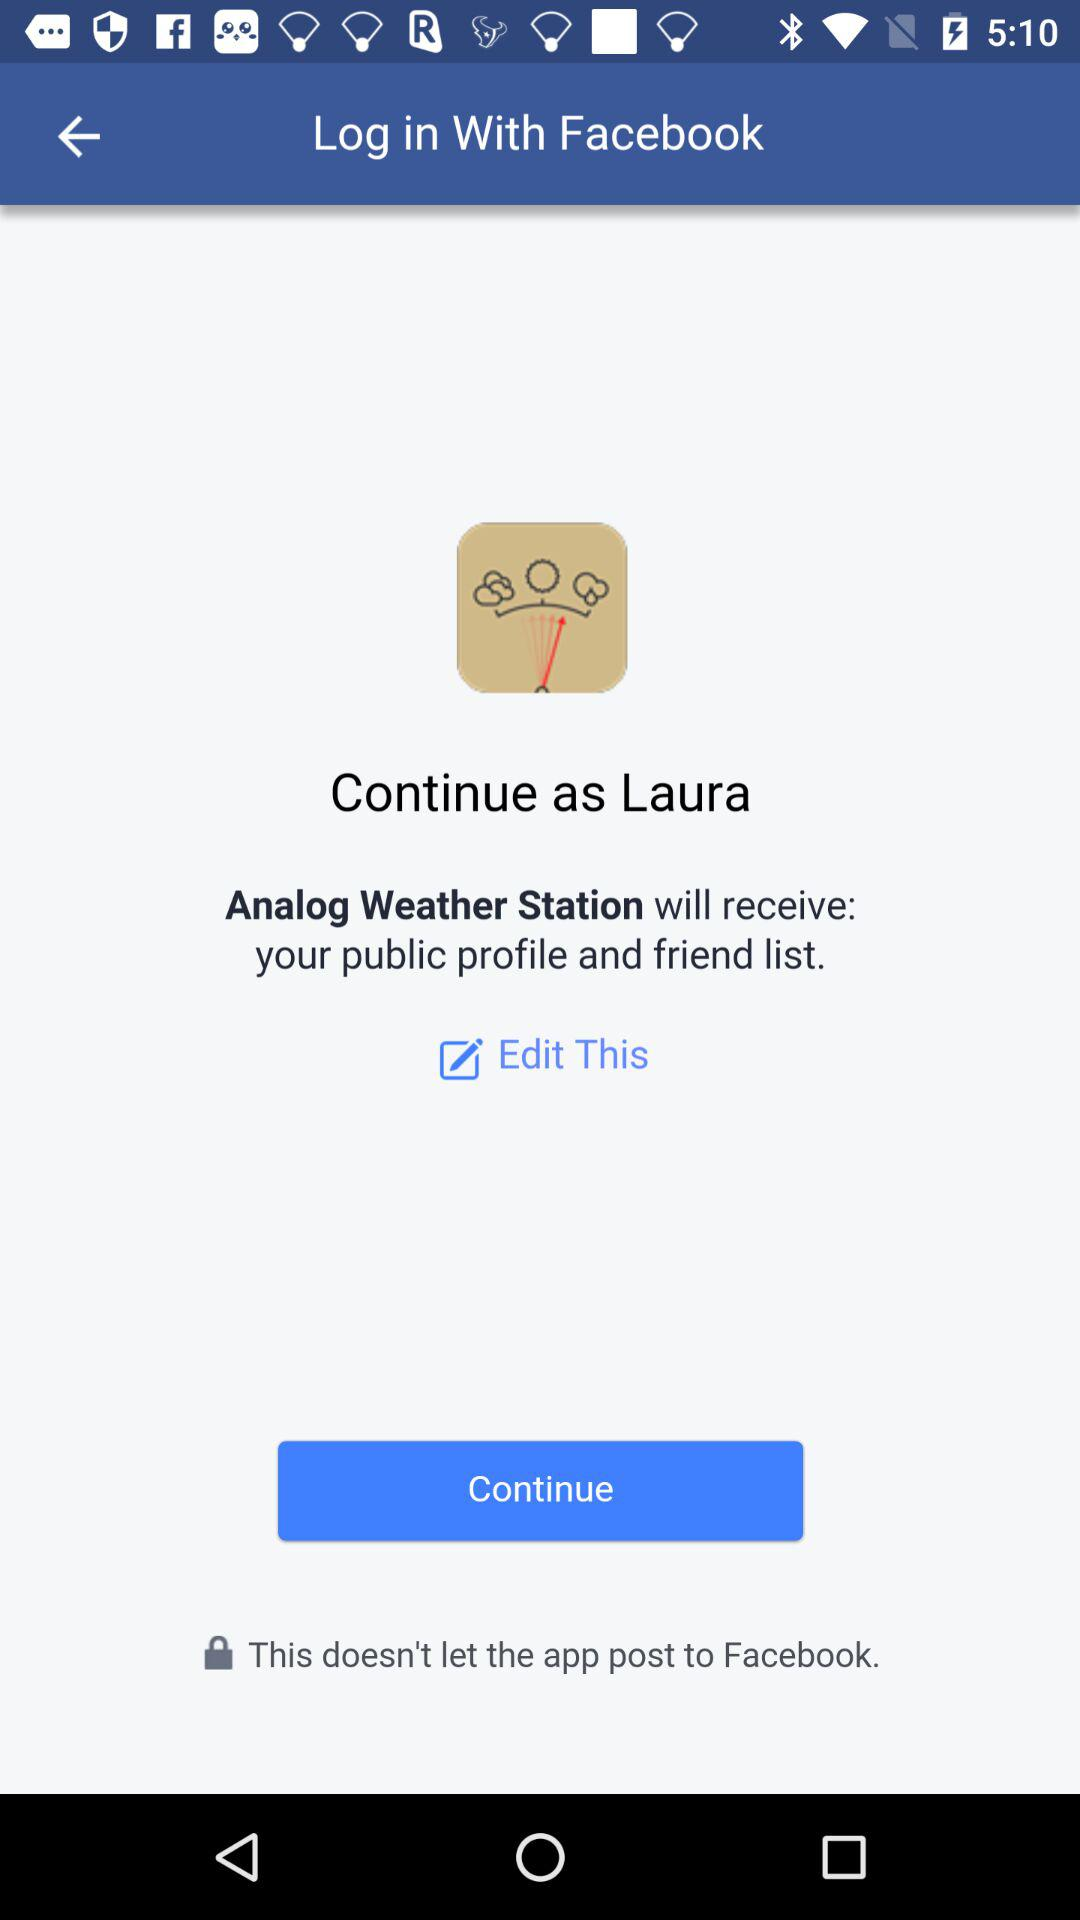What application is asking for permission? The application asking for permission is "Analog Weather Station". 